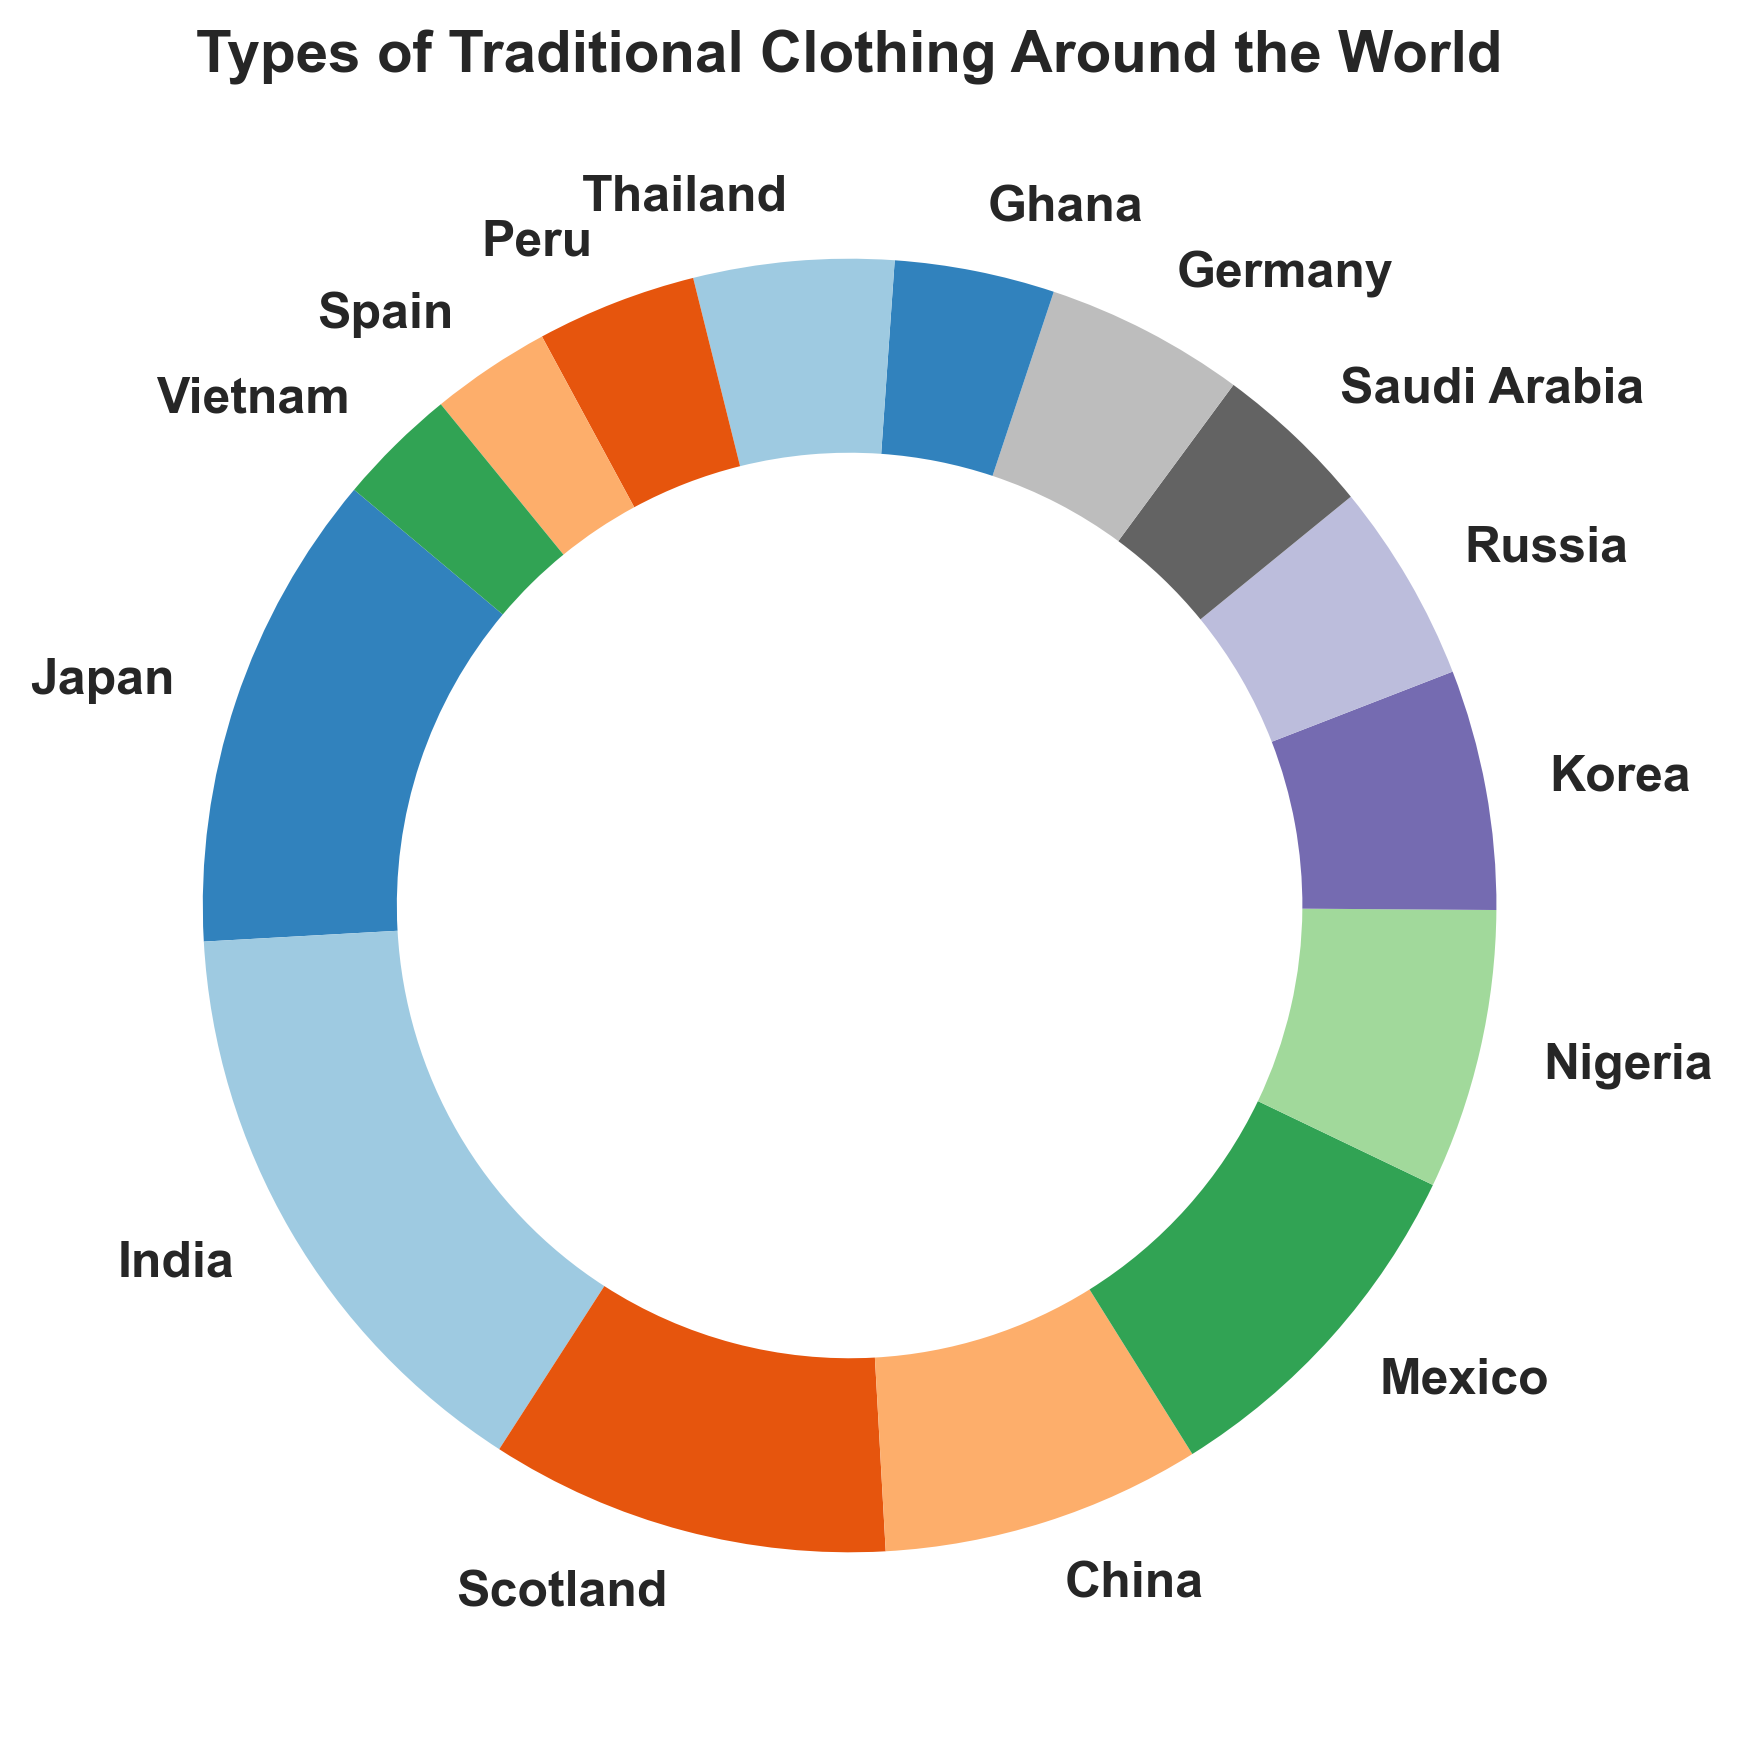What is the percentage of traditional clothing from India? The percentage of traditional clothing from India (Sari) can be directly read from the figure.
Answer: 15% Which country's traditional clothing occupies the largest section? By visual inspection, the largest section in the ring chart corresponds to India (Sari) with 15%.
Answer: India What is the combined percentage of traditional clothing from Japan and Korea? To find the combined percentage, add the individual percentages of traditional clothing from Japan and Korea: 12% (Kimono) + 6% (Hanbok) = 18%.
Answer: 18% Is the percentage of traditional clothing from Mexico greater than that from Korea? Compare the percentages from Mexico (9%) and Korea (6%). 9% is greater than 6%.
Answer: Yes What is the sum of the percentages of traditional clothing from Germany, Spain, and Saudi Arabia? Add the percentages for Germany (5%), Spain (3%), and Saudi Arabia (4%): 5% + 3% + 4% = 12%.
Answer: 12% Which colors visually represent the traditional clothing from Nigeria and Ghana? By looking at the ring chart, identify the colors corresponding to Nigeria and Ghana. Nigeria is one section away from the starting point (12% of Japan, 15% of India, 10% of Scotland, and 8% of China), which is orange. Ghana is near the end and is green.
Answer: Orange and Green What is the average percentage of traditional clothing from Thailand, Russia, and Peru? Calculate the average of the percentages: (5% + 5% + 4%) / 3 = 4.67%.
Answer: 4.67% Is the combined percentage of traditional clothing from Japan, China, and Vietnam greater or lesser than 25%? Calculate the combined percentage and compare it with 25%. Japan (12%) + China (8%) + Vietnam (3%) = 23%. Since 23% is less than 25%, the answer is lesser.
Answer: Lesser Which traditional clothing has a smaller percentage, Áo Dài from Vietnam or Flamenco Dress from Spain? Compare the percentages of Áo Dài (Vietnam, 3%) and Flamenco Dress (Spain, 3%). Both have the same percentage.
Answer: Equal What is the difference in percentage between the largest and smallest traditional clothing sections? The largest section is India (15%) and the smallest sections are Spain and Vietnam (3%). The difference is 15% - 3% = 12%.
Answer: 12% 